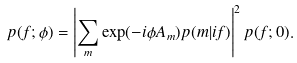<formula> <loc_0><loc_0><loc_500><loc_500>p ( f ; \phi ) = \left | \sum _ { m } \exp ( - i \phi A _ { m } ) p ( m | i f ) \right | ^ { 2 } p ( f ; 0 ) .</formula> 